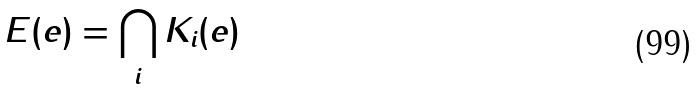<formula> <loc_0><loc_0><loc_500><loc_500>E ( e ) = \bigcap _ { i } K _ { i } ( e )</formula> 